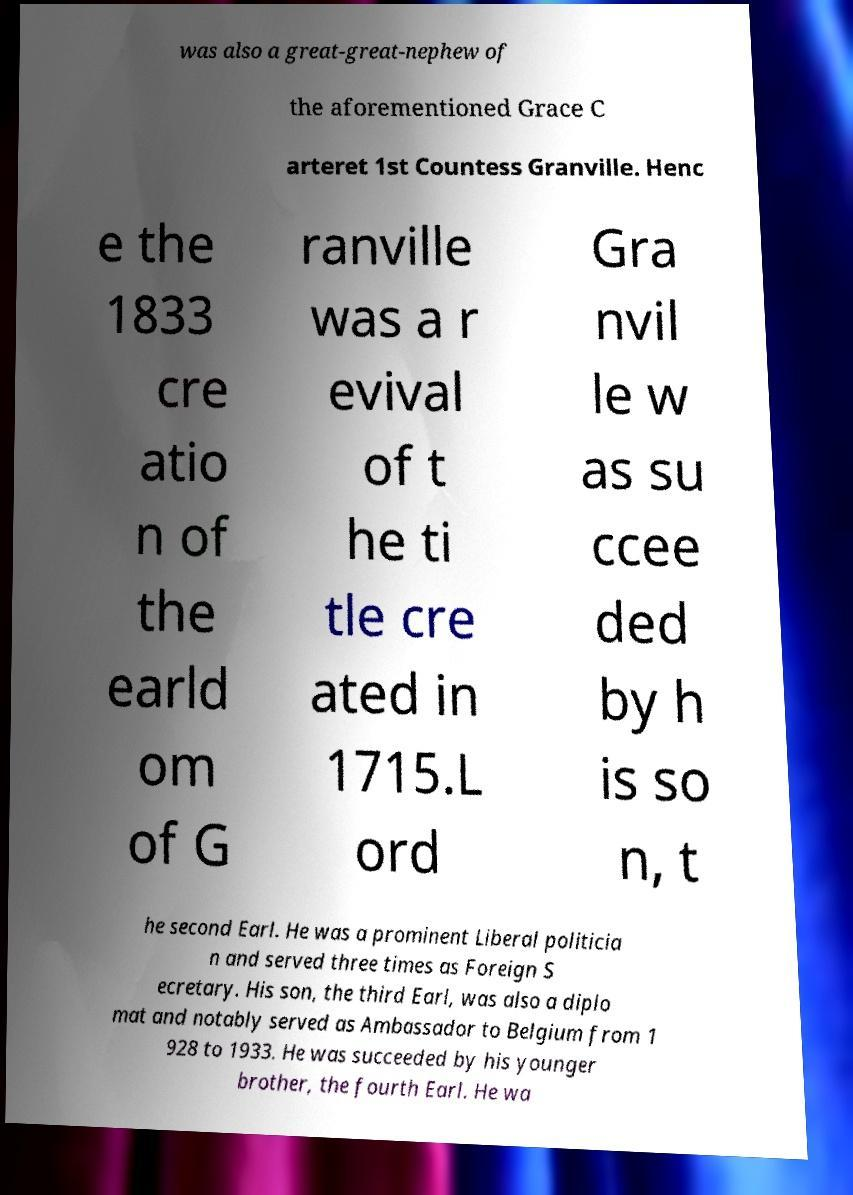For documentation purposes, I need the text within this image transcribed. Could you provide that? was also a great-great-nephew of the aforementioned Grace C arteret 1st Countess Granville. Henc e the 1833 cre atio n of the earld om of G ranville was a r evival of t he ti tle cre ated in 1715.L ord Gra nvil le w as su ccee ded by h is so n, t he second Earl. He was a prominent Liberal politicia n and served three times as Foreign S ecretary. His son, the third Earl, was also a diplo mat and notably served as Ambassador to Belgium from 1 928 to 1933. He was succeeded by his younger brother, the fourth Earl. He wa 